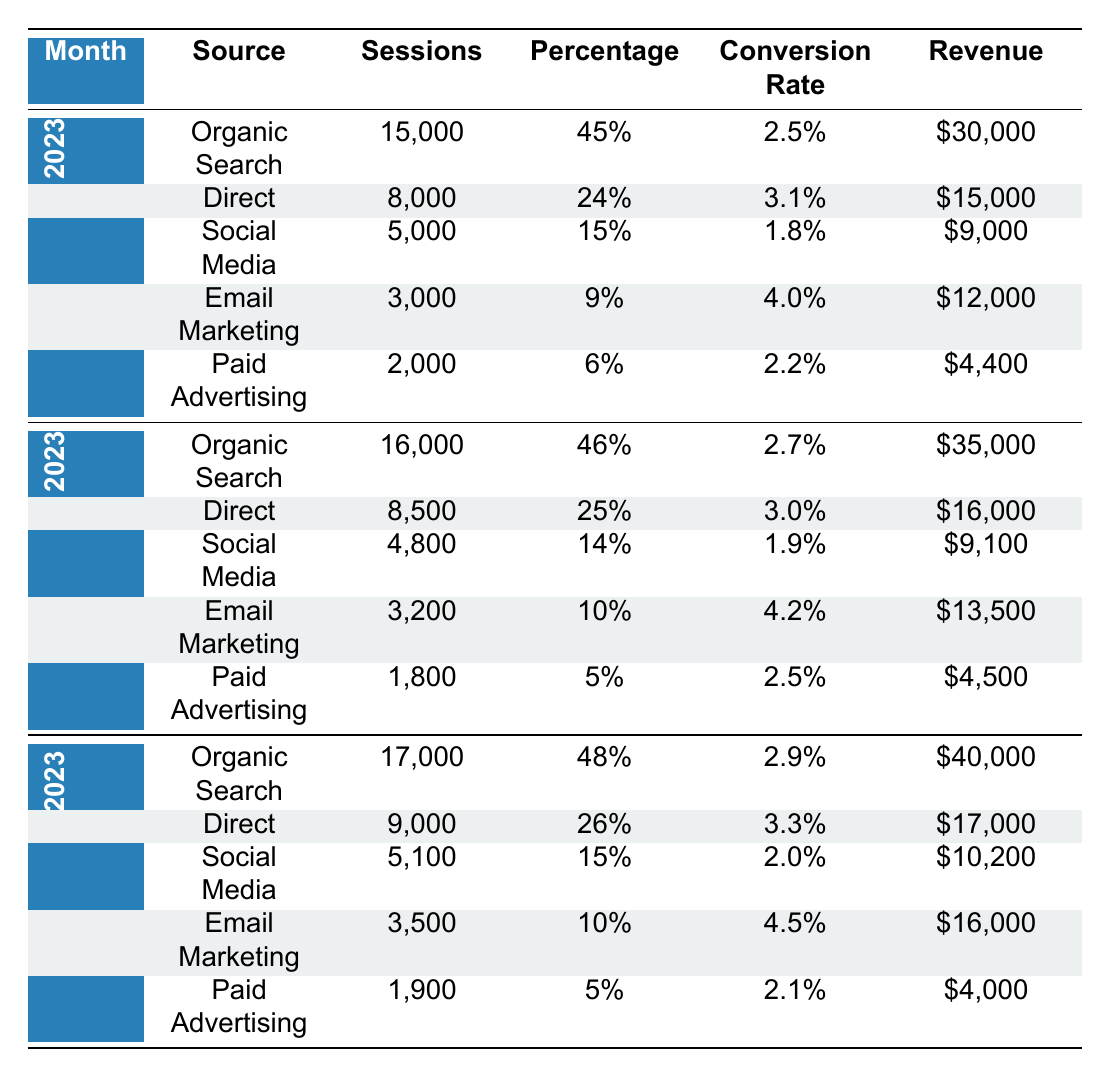What is the total revenue from Organic Search in January 2023? The revenue from Organic Search in January 2023 is $30,000. There are no additional sources to sum here since the question specifically asks about Organic Search.
Answer: $30,000 What was the highest source of traffic in February 2023? The highest source of traffic in February 2023 was Organic Search with 16,000 sessions. Tracing through the rows for that month, Organic Search has the highest sessions compared to other sources.
Answer: Organic Search What is the conversion rate for Email Marketing in March 2023? The conversion rate for Email Marketing in March 2023 is 4.5%. This value is directly found in the table under the corresponding month and source.
Answer: 4.5% Which month had a total of 9,000 sessions from Direct traffic? The month with a total of 9,000 sessions from Direct traffic is March 2023. In the table, the row for March lists Direct traffic with exactly 9,000 sessions.
Answer: March 2023 Is the conversion rate for Paid Advertising higher in January 2023 than in February 2023? In January 2023, the conversion rate for Paid Advertising is 2.2%, and in February 2023, it is 2.5%. Comparing these values shows that 2.2% is lower than 2.5%. Thus, the statement is false.
Answer: No What was the percentage of sessions from Social Media across all three months? For January, Social Media had 15%; for February, it was 14%; and for March, it was 15%. To find the overall percentage, we average these: (15 + 14 + 15) / 3 = 14.67%.
Answer: 14.67% How much revenue did Direct traffic generate in total over the three months? In January, Direct earned $15,000; in February, it earned $16,000; and in March, it earned $17,000. Summing these values gives $15,000 + $16,000 + $17,000 = $48,000.
Answer: $48,000 In which month did Email Marketing achieve its highest conversion rate? Email Marketing had its highest conversion rate in March 2023 with a rate of 4.5%. Comparing the rates of 4.0% in January and 4.2% in February confirms that March has the highest.
Answer: March 2023 Was the total number of sessions in February 2023 greater than in January 2023? In January 2023, the total sessions were 15,000 + 8,000 + 5,000 + 3,000 + 2,000 = 33,000. In February 2023, the totals are 16,000 + 8,500 + 4,800 + 3,200 + 1,800 = 34,300. Comparing both, 34,300 is greater than 33,000, making the statement true.
Answer: Yes 